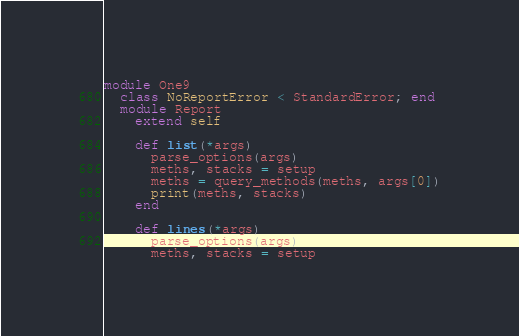Convert code to text. <code><loc_0><loc_0><loc_500><loc_500><_Ruby_>module One9
  class NoReportError < StandardError; end
  module Report
    extend self

    def list(*args)
      parse_options(args)
      meths, stacks = setup
      meths = query_methods(meths, args[0])
      print(meths, stacks)
    end

    def lines(*args)
      parse_options(args)
      meths, stacks = setup</code> 